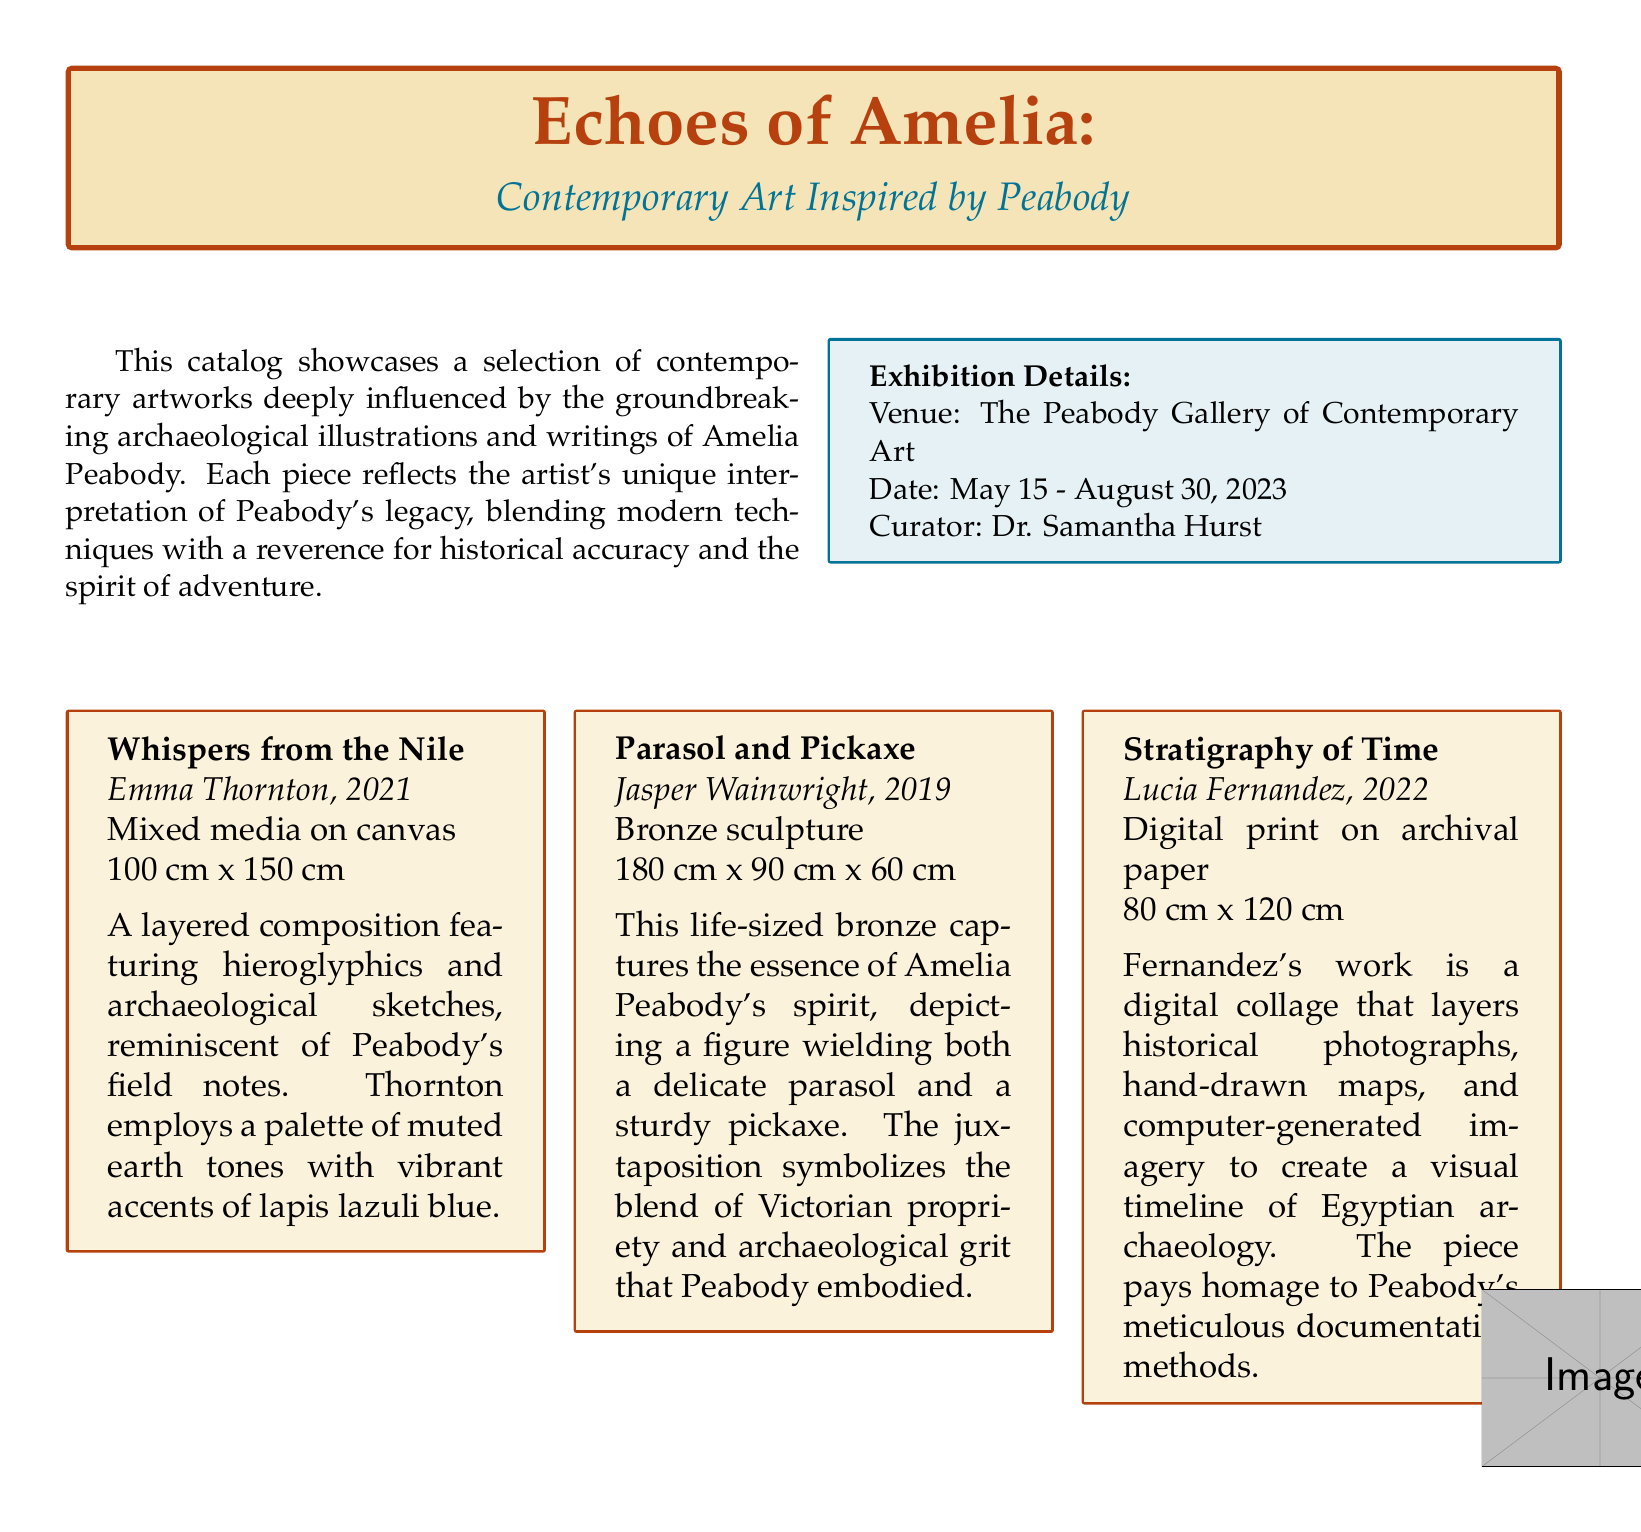What is the exhibition title? The title of the exhibition is displayed prominently at the beginning of the catalog, highlighting the theme of contemporary art inspired by Amelia Peabody's works.
Answer: Echoes of Amelia Who is the curator of the exhibition? The curator is mentioned in the exhibition details box, indicating who is responsible for the exhibition's organization and curation.
Answer: Dr. Samantha Hurst What are the dates of the exhibition? The catalog provides starting and ending dates for the exhibition, outlining its duration for visitors.
Answer: May 15 - August 30, 2023 What type of artwork is "Whispers from the Nile"? This question identifies the medium used in the specific piece of art described in the catalog.
Answer: Mixed media on canvas How tall is the sculpture "Parasol and Pickaxe"? The height of the sculpture is noted in its description, providing dimensions for understanding its scale.
Answer: 180 cm What color accents are used in "Whispers from the Nile"? The description explains the color palette used in the artwork and highlights certain prominent colors.
Answer: Lapis lazuli blue What does the sculpture "Parasol and Pickaxe" symbolize? The description in the catalog provides insight into the thematic representation of the sculpture and its inherent symbolism.
Answer: Blend of Victorian propriety and archaeological grit What technique is used in "Stratigraphy of Time"? This question addresses the artistic approach applied in the specific artwork, as detailed in the catalog.
Answer: Digital collage What kind of imagery is in "Stratigraphy of Time"? The artist's description specifies the elements that constitute the artwork, summarizing its visual composition.
Answer: Historical photographs, hand-drawn maps, computer-generated imagery 